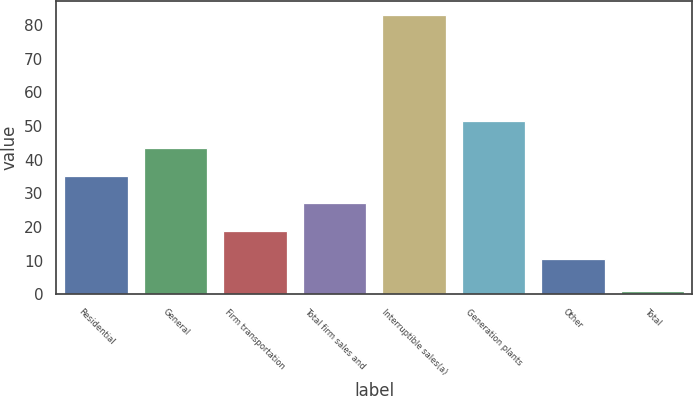<chart> <loc_0><loc_0><loc_500><loc_500><bar_chart><fcel>Residential<fcel>General<fcel>Firm transportation<fcel>Total firm sales and<fcel>Interruptible sales(a)<fcel>Generation plants<fcel>Other<fcel>Total<nl><fcel>35.2<fcel>43.4<fcel>18.8<fcel>27<fcel>82.9<fcel>51.6<fcel>10.6<fcel>0.9<nl></chart> 